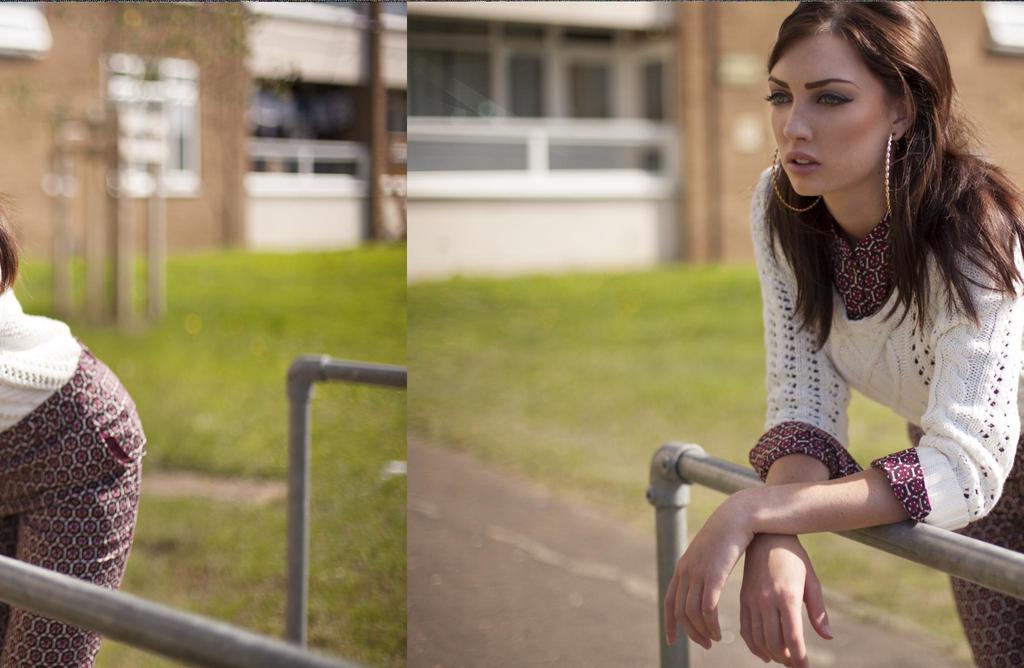Please provide a concise description of this image. Here we can see a collage picture. In the picture we can see a woman, grass, rods, and a building. 